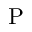<formula> <loc_0><loc_0><loc_500><loc_500>P</formula> 